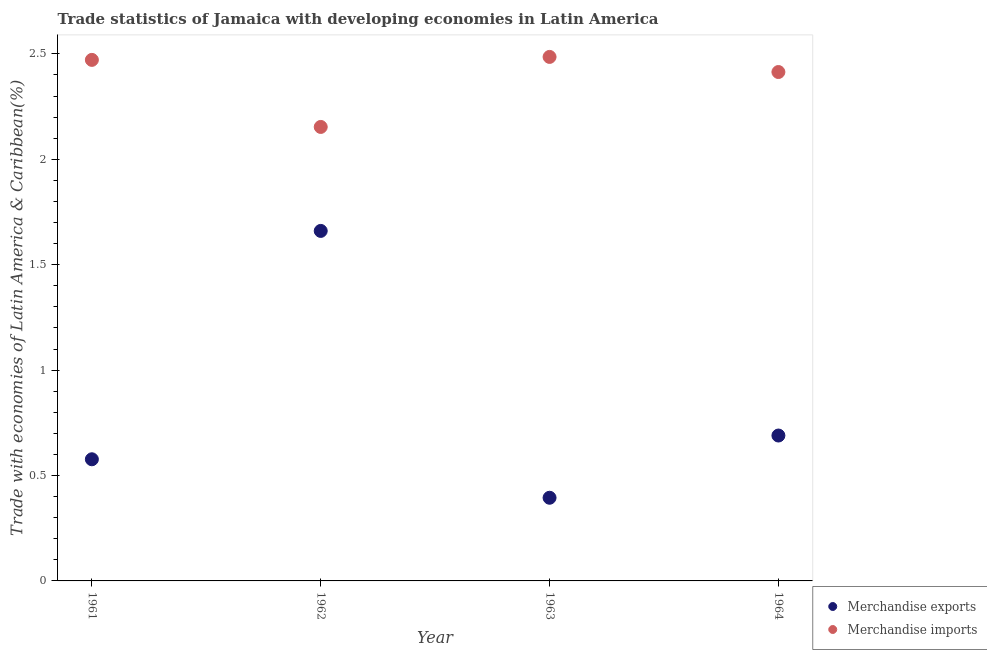How many different coloured dotlines are there?
Ensure brevity in your answer.  2. Is the number of dotlines equal to the number of legend labels?
Provide a short and direct response. Yes. What is the merchandise exports in 1962?
Provide a short and direct response. 1.66. Across all years, what is the maximum merchandise imports?
Offer a terse response. 2.49. Across all years, what is the minimum merchandise imports?
Your response must be concise. 2.15. What is the total merchandise exports in the graph?
Keep it short and to the point. 3.32. What is the difference between the merchandise exports in 1961 and that in 1962?
Give a very brief answer. -1.08. What is the difference between the merchandise imports in 1963 and the merchandise exports in 1964?
Your response must be concise. 1.8. What is the average merchandise imports per year?
Make the answer very short. 2.38. In the year 1962, what is the difference between the merchandise imports and merchandise exports?
Your response must be concise. 0.49. What is the ratio of the merchandise imports in 1961 to that in 1963?
Offer a terse response. 0.99. Is the merchandise imports in 1961 less than that in 1962?
Ensure brevity in your answer.  No. What is the difference between the highest and the second highest merchandise imports?
Give a very brief answer. 0.01. What is the difference between the highest and the lowest merchandise exports?
Offer a terse response. 1.27. Is the sum of the merchandise exports in 1962 and 1964 greater than the maximum merchandise imports across all years?
Offer a terse response. No. How many dotlines are there?
Ensure brevity in your answer.  2. How many years are there in the graph?
Offer a terse response. 4. Does the graph contain grids?
Keep it short and to the point. No. Where does the legend appear in the graph?
Offer a very short reply. Bottom right. What is the title of the graph?
Keep it short and to the point. Trade statistics of Jamaica with developing economies in Latin America. What is the label or title of the Y-axis?
Ensure brevity in your answer.  Trade with economies of Latin America & Caribbean(%). What is the Trade with economies of Latin America & Caribbean(%) in Merchandise exports in 1961?
Keep it short and to the point. 0.58. What is the Trade with economies of Latin America & Caribbean(%) in Merchandise imports in 1961?
Your answer should be very brief. 2.47. What is the Trade with economies of Latin America & Caribbean(%) in Merchandise exports in 1962?
Your answer should be very brief. 1.66. What is the Trade with economies of Latin America & Caribbean(%) of Merchandise imports in 1962?
Keep it short and to the point. 2.15. What is the Trade with economies of Latin America & Caribbean(%) in Merchandise exports in 1963?
Keep it short and to the point. 0.39. What is the Trade with economies of Latin America & Caribbean(%) in Merchandise imports in 1963?
Keep it short and to the point. 2.49. What is the Trade with economies of Latin America & Caribbean(%) in Merchandise exports in 1964?
Provide a short and direct response. 0.69. What is the Trade with economies of Latin America & Caribbean(%) in Merchandise imports in 1964?
Your answer should be very brief. 2.41. Across all years, what is the maximum Trade with economies of Latin America & Caribbean(%) in Merchandise exports?
Your response must be concise. 1.66. Across all years, what is the maximum Trade with economies of Latin America & Caribbean(%) of Merchandise imports?
Ensure brevity in your answer.  2.49. Across all years, what is the minimum Trade with economies of Latin America & Caribbean(%) in Merchandise exports?
Offer a terse response. 0.39. Across all years, what is the minimum Trade with economies of Latin America & Caribbean(%) in Merchandise imports?
Offer a terse response. 2.15. What is the total Trade with economies of Latin America & Caribbean(%) of Merchandise exports in the graph?
Make the answer very short. 3.32. What is the total Trade with economies of Latin America & Caribbean(%) in Merchandise imports in the graph?
Ensure brevity in your answer.  9.52. What is the difference between the Trade with economies of Latin America & Caribbean(%) in Merchandise exports in 1961 and that in 1962?
Provide a succinct answer. -1.08. What is the difference between the Trade with economies of Latin America & Caribbean(%) of Merchandise imports in 1961 and that in 1962?
Provide a succinct answer. 0.32. What is the difference between the Trade with economies of Latin America & Caribbean(%) in Merchandise exports in 1961 and that in 1963?
Make the answer very short. 0.18. What is the difference between the Trade with economies of Latin America & Caribbean(%) of Merchandise imports in 1961 and that in 1963?
Offer a very short reply. -0.01. What is the difference between the Trade with economies of Latin America & Caribbean(%) of Merchandise exports in 1961 and that in 1964?
Offer a very short reply. -0.11. What is the difference between the Trade with economies of Latin America & Caribbean(%) of Merchandise imports in 1961 and that in 1964?
Make the answer very short. 0.06. What is the difference between the Trade with economies of Latin America & Caribbean(%) of Merchandise exports in 1962 and that in 1963?
Offer a terse response. 1.27. What is the difference between the Trade with economies of Latin America & Caribbean(%) in Merchandise imports in 1962 and that in 1963?
Ensure brevity in your answer.  -0.33. What is the difference between the Trade with economies of Latin America & Caribbean(%) of Merchandise exports in 1962 and that in 1964?
Give a very brief answer. 0.97. What is the difference between the Trade with economies of Latin America & Caribbean(%) of Merchandise imports in 1962 and that in 1964?
Your answer should be compact. -0.26. What is the difference between the Trade with economies of Latin America & Caribbean(%) in Merchandise exports in 1963 and that in 1964?
Your answer should be compact. -0.3. What is the difference between the Trade with economies of Latin America & Caribbean(%) of Merchandise imports in 1963 and that in 1964?
Your response must be concise. 0.07. What is the difference between the Trade with economies of Latin America & Caribbean(%) in Merchandise exports in 1961 and the Trade with economies of Latin America & Caribbean(%) in Merchandise imports in 1962?
Provide a succinct answer. -1.58. What is the difference between the Trade with economies of Latin America & Caribbean(%) in Merchandise exports in 1961 and the Trade with economies of Latin America & Caribbean(%) in Merchandise imports in 1963?
Make the answer very short. -1.91. What is the difference between the Trade with economies of Latin America & Caribbean(%) in Merchandise exports in 1961 and the Trade with economies of Latin America & Caribbean(%) in Merchandise imports in 1964?
Your response must be concise. -1.84. What is the difference between the Trade with economies of Latin America & Caribbean(%) of Merchandise exports in 1962 and the Trade with economies of Latin America & Caribbean(%) of Merchandise imports in 1963?
Give a very brief answer. -0.83. What is the difference between the Trade with economies of Latin America & Caribbean(%) of Merchandise exports in 1962 and the Trade with economies of Latin America & Caribbean(%) of Merchandise imports in 1964?
Provide a short and direct response. -0.75. What is the difference between the Trade with economies of Latin America & Caribbean(%) of Merchandise exports in 1963 and the Trade with economies of Latin America & Caribbean(%) of Merchandise imports in 1964?
Your answer should be compact. -2.02. What is the average Trade with economies of Latin America & Caribbean(%) in Merchandise exports per year?
Offer a very short reply. 0.83. What is the average Trade with economies of Latin America & Caribbean(%) in Merchandise imports per year?
Your answer should be very brief. 2.38. In the year 1961, what is the difference between the Trade with economies of Latin America & Caribbean(%) of Merchandise exports and Trade with economies of Latin America & Caribbean(%) of Merchandise imports?
Keep it short and to the point. -1.89. In the year 1962, what is the difference between the Trade with economies of Latin America & Caribbean(%) of Merchandise exports and Trade with economies of Latin America & Caribbean(%) of Merchandise imports?
Give a very brief answer. -0.49. In the year 1963, what is the difference between the Trade with economies of Latin America & Caribbean(%) of Merchandise exports and Trade with economies of Latin America & Caribbean(%) of Merchandise imports?
Give a very brief answer. -2.09. In the year 1964, what is the difference between the Trade with economies of Latin America & Caribbean(%) in Merchandise exports and Trade with economies of Latin America & Caribbean(%) in Merchandise imports?
Offer a very short reply. -1.72. What is the ratio of the Trade with economies of Latin America & Caribbean(%) of Merchandise exports in 1961 to that in 1962?
Your answer should be compact. 0.35. What is the ratio of the Trade with economies of Latin America & Caribbean(%) in Merchandise imports in 1961 to that in 1962?
Give a very brief answer. 1.15. What is the ratio of the Trade with economies of Latin America & Caribbean(%) of Merchandise exports in 1961 to that in 1963?
Ensure brevity in your answer.  1.46. What is the ratio of the Trade with economies of Latin America & Caribbean(%) of Merchandise imports in 1961 to that in 1963?
Ensure brevity in your answer.  0.99. What is the ratio of the Trade with economies of Latin America & Caribbean(%) of Merchandise exports in 1961 to that in 1964?
Your answer should be compact. 0.84. What is the ratio of the Trade with economies of Latin America & Caribbean(%) of Merchandise imports in 1961 to that in 1964?
Offer a terse response. 1.02. What is the ratio of the Trade with economies of Latin America & Caribbean(%) in Merchandise exports in 1962 to that in 1963?
Your answer should be compact. 4.21. What is the ratio of the Trade with economies of Latin America & Caribbean(%) in Merchandise imports in 1962 to that in 1963?
Provide a succinct answer. 0.87. What is the ratio of the Trade with economies of Latin America & Caribbean(%) in Merchandise exports in 1962 to that in 1964?
Offer a terse response. 2.41. What is the ratio of the Trade with economies of Latin America & Caribbean(%) in Merchandise imports in 1962 to that in 1964?
Offer a very short reply. 0.89. What is the ratio of the Trade with economies of Latin America & Caribbean(%) in Merchandise exports in 1963 to that in 1964?
Your answer should be very brief. 0.57. What is the ratio of the Trade with economies of Latin America & Caribbean(%) in Merchandise imports in 1963 to that in 1964?
Give a very brief answer. 1.03. What is the difference between the highest and the second highest Trade with economies of Latin America & Caribbean(%) in Merchandise exports?
Provide a succinct answer. 0.97. What is the difference between the highest and the second highest Trade with economies of Latin America & Caribbean(%) in Merchandise imports?
Make the answer very short. 0.01. What is the difference between the highest and the lowest Trade with economies of Latin America & Caribbean(%) of Merchandise exports?
Ensure brevity in your answer.  1.27. What is the difference between the highest and the lowest Trade with economies of Latin America & Caribbean(%) of Merchandise imports?
Your answer should be very brief. 0.33. 